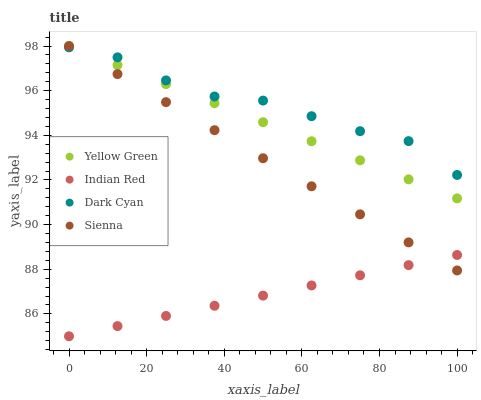Does Indian Red have the minimum area under the curve?
Answer yes or no. Yes. Does Dark Cyan have the maximum area under the curve?
Answer yes or no. Yes. Does Sienna have the minimum area under the curve?
Answer yes or no. No. Does Sienna have the maximum area under the curve?
Answer yes or no. No. Is Indian Red the smoothest?
Answer yes or no. Yes. Is Dark Cyan the roughest?
Answer yes or no. Yes. Is Sienna the smoothest?
Answer yes or no. No. Is Sienna the roughest?
Answer yes or no. No. Does Indian Red have the lowest value?
Answer yes or no. Yes. Does Sienna have the lowest value?
Answer yes or no. No. Does Yellow Green have the highest value?
Answer yes or no. Yes. Does Indian Red have the highest value?
Answer yes or no. No. Is Indian Red less than Yellow Green?
Answer yes or no. Yes. Is Dark Cyan greater than Indian Red?
Answer yes or no. Yes. Does Dark Cyan intersect Yellow Green?
Answer yes or no. Yes. Is Dark Cyan less than Yellow Green?
Answer yes or no. No. Is Dark Cyan greater than Yellow Green?
Answer yes or no. No. Does Indian Red intersect Yellow Green?
Answer yes or no. No. 